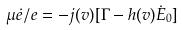<formula> <loc_0><loc_0><loc_500><loc_500>\mu \dot { e } / e = - j ( v ) [ \Gamma - h ( v ) \dot { E } _ { 0 } ]</formula> 